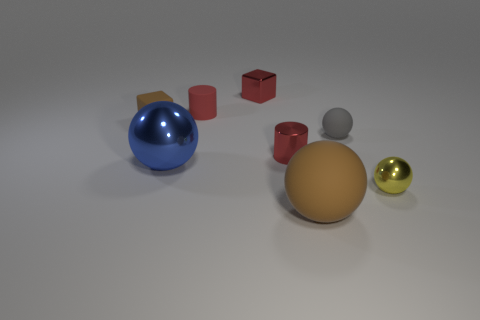There is a small thing that is the same color as the large matte thing; what shape is it?
Offer a terse response. Cube. What is the color of the block that is to the right of the big ball on the left side of the small red matte thing behind the large metallic thing?
Your response must be concise. Red. There is a brown thing that is behind the tiny matte sphere; is its shape the same as the tiny yellow metallic object?
Make the answer very short. No. What is the large brown object made of?
Offer a terse response. Rubber. There is a shiny thing that is to the right of the matte sphere that is in front of the thing right of the small gray matte object; what is its shape?
Your answer should be compact. Sphere. How many other objects are there of the same shape as the blue thing?
Provide a short and direct response. 3. There is a tiny matte cylinder; is it the same color as the ball that is in front of the small yellow metallic object?
Ensure brevity in your answer.  No. What number of tiny shiny objects are there?
Your answer should be compact. 3. What number of objects are tiny red cylinders or red shiny objects?
Your answer should be very brief. 3. The cube that is the same color as the large matte thing is what size?
Offer a very short reply. Small. 